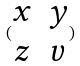Convert formula to latex. <formula><loc_0><loc_0><loc_500><loc_500>( \begin{matrix} x & y \\ z & v \end{matrix} )</formula> 